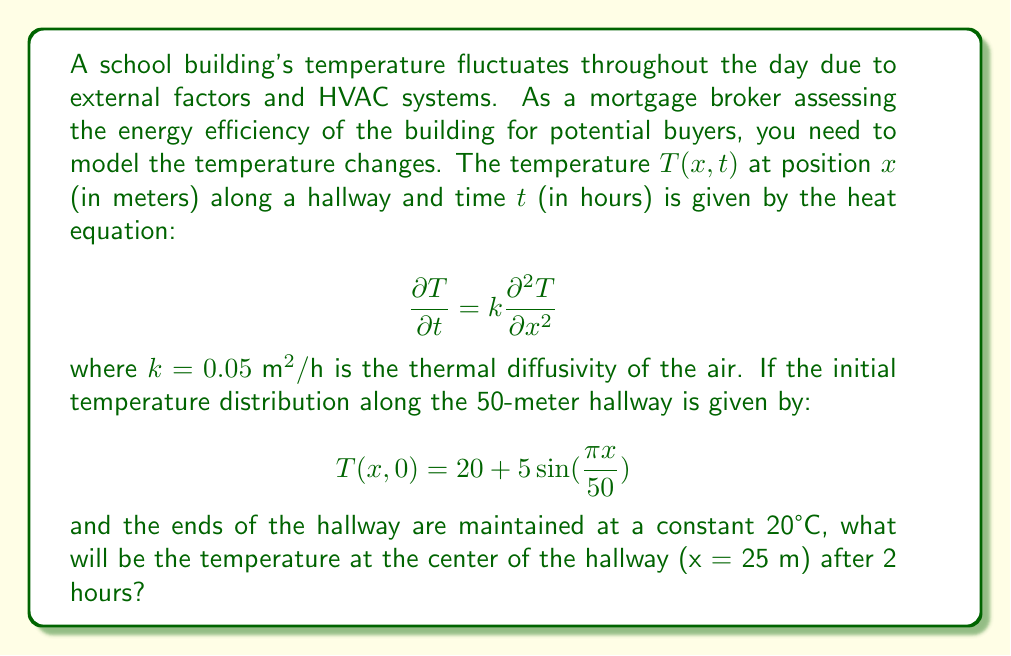What is the answer to this math problem? To solve this problem, we need to use the solution to the heat equation with the given initial and boundary conditions. The general solution for this scenario is:

$$T(x,t) = 20 + \sum_{n=1}^{\infty} B_n \sin(\frac{n\pi x}{L})e^{-(\frac{n\pi}{L})^2kt}$$

where $L = 50$ m is the length of the hallway.

Steps to solve:

1) First, we need to find $B_n$. Given the initial condition:

   $$T(x,0) = 20 + 5\sin(\frac{\pi x}{50})$$

   We can see that only the first term in the series ($n=1$) is non-zero, and $B_1 = 5$.

2) Now our solution simplifies to:

   $$T(x,t) = 20 + 5\sin(\frac{\pi x}{50})e^{-(\frac{\pi}{50})^2kt}$$

3) We want to find $T(25,2)$, so let's substitute $x=25$, $t=2$, and $k=0.05$:

   $$T(25,2) = 20 + 5\sin(\frac{\pi \cdot 25}{50})e^{-(\frac{\pi}{50})^2 \cdot 0.05 \cdot 2}$$

4) Simplify:
   
   $$T(25,2) = 20 + 5\sin(\frac{\pi}{2})e^{-0.000395}$$

5) Calculate:
   
   $$T(25,2) = 20 + 5 \cdot 1 \cdot 0.9996 = 24.998°C$$

Therefore, after 2 hours, the temperature at the center of the hallway will be approximately 24.998°C.
Answer: 24.998°C 